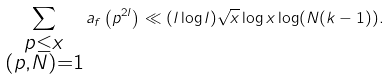<formula> <loc_0><loc_0><loc_500><loc_500>\sum _ { \substack { p \leq x \\ ( p , N ) = 1 } } a _ { f } \left ( p ^ { 2 l } \right ) \ll ( l \log l ) \sqrt { x } \log x \log ( N ( k - 1 ) ) .</formula> 